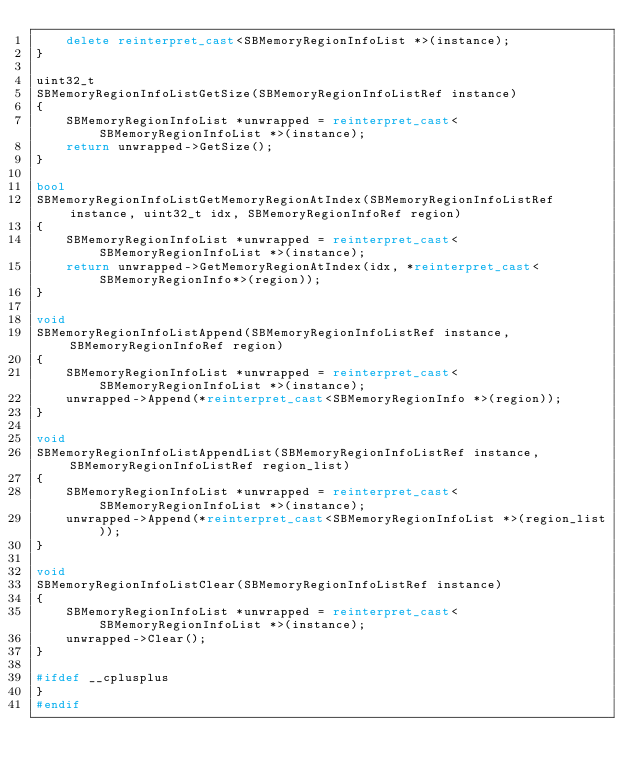Convert code to text. <code><loc_0><loc_0><loc_500><loc_500><_C++_>    delete reinterpret_cast<SBMemoryRegionInfoList *>(instance);
}

uint32_t
SBMemoryRegionInfoListGetSize(SBMemoryRegionInfoListRef instance)
{
    SBMemoryRegionInfoList *unwrapped = reinterpret_cast<SBMemoryRegionInfoList *>(instance);
    return unwrapped->GetSize();
}

bool
SBMemoryRegionInfoListGetMemoryRegionAtIndex(SBMemoryRegionInfoListRef instance, uint32_t idx, SBMemoryRegionInfoRef region)
{
    SBMemoryRegionInfoList *unwrapped = reinterpret_cast<SBMemoryRegionInfoList *>(instance);
    return unwrapped->GetMemoryRegionAtIndex(idx, *reinterpret_cast<SBMemoryRegionInfo*>(region));
}

void
SBMemoryRegionInfoListAppend(SBMemoryRegionInfoListRef instance, SBMemoryRegionInfoRef region)
{
    SBMemoryRegionInfoList *unwrapped = reinterpret_cast<SBMemoryRegionInfoList *>(instance);
    unwrapped->Append(*reinterpret_cast<SBMemoryRegionInfo *>(region));
}

void
SBMemoryRegionInfoListAppendList(SBMemoryRegionInfoListRef instance, SBMemoryRegionInfoListRef region_list)
{
    SBMemoryRegionInfoList *unwrapped = reinterpret_cast<SBMemoryRegionInfoList *>(instance);
    unwrapped->Append(*reinterpret_cast<SBMemoryRegionInfoList *>(region_list));
}

void
SBMemoryRegionInfoListClear(SBMemoryRegionInfoListRef instance)
{
    SBMemoryRegionInfoList *unwrapped = reinterpret_cast<SBMemoryRegionInfoList *>(instance);
    unwrapped->Clear();
}

#ifdef __cplusplus
}
#endif
</code> 